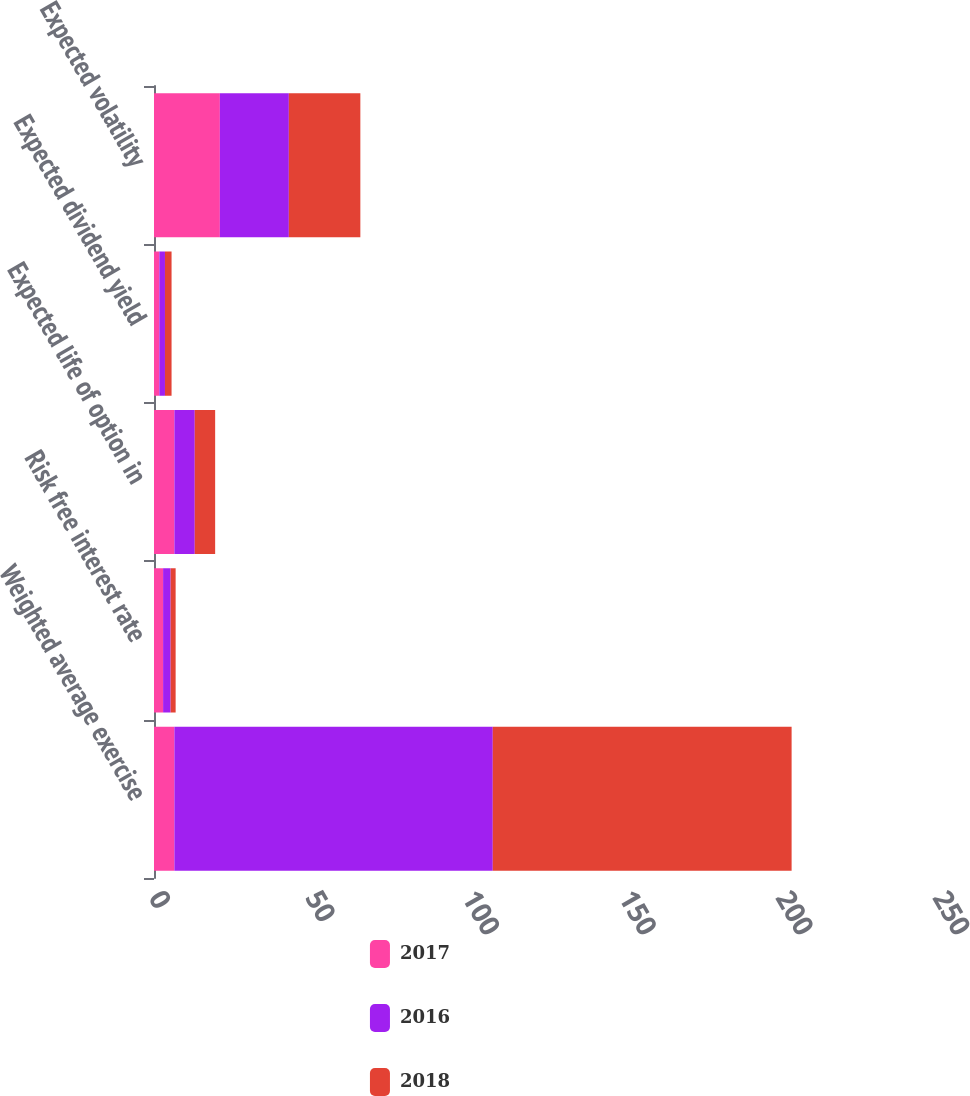Convert chart. <chart><loc_0><loc_0><loc_500><loc_500><stacked_bar_chart><ecel><fcel>Weighted average exercise<fcel>Risk free interest rate<fcel>Expected life of option in<fcel>Expected dividend yield<fcel>Expected volatility<nl><fcel>2017<fcel>6.5<fcel>2.9<fcel>6.5<fcel>1.7<fcel>21<nl><fcel>2016<fcel>101.53<fcel>2.4<fcel>6.5<fcel>1.8<fcel>22<nl><fcel>2018<fcel>95.29<fcel>1.6<fcel>6.5<fcel>2.1<fcel>22.8<nl></chart> 